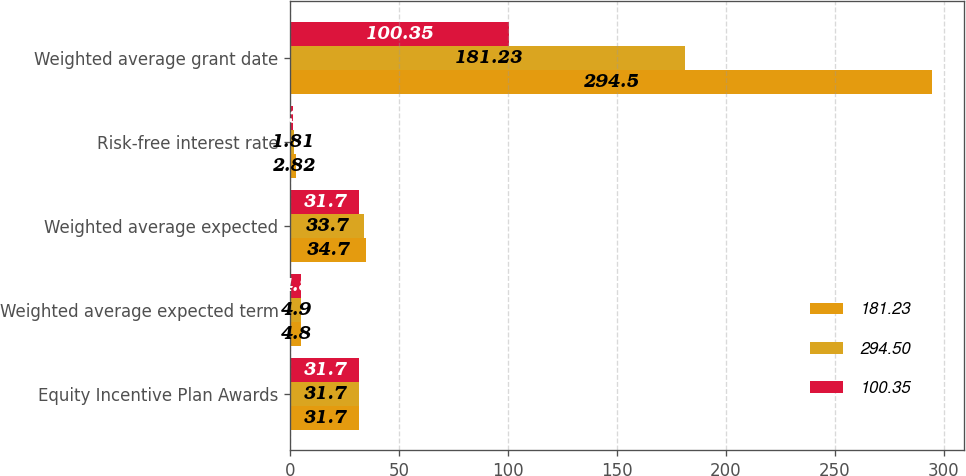Convert chart to OTSL. <chart><loc_0><loc_0><loc_500><loc_500><stacked_bar_chart><ecel><fcel>Equity Incentive Plan Awards<fcel>Weighted average expected term<fcel>Weighted average expected<fcel>Risk-free interest rate<fcel>Weighted average grant date<nl><fcel>181.23<fcel>31.7<fcel>4.8<fcel>34.7<fcel>2.82<fcel>294.5<nl><fcel>294.5<fcel>31.7<fcel>4.9<fcel>33.7<fcel>1.81<fcel>181.23<nl><fcel>100.35<fcel>31.7<fcel>4.8<fcel>31.7<fcel>1.32<fcel>100.35<nl></chart> 